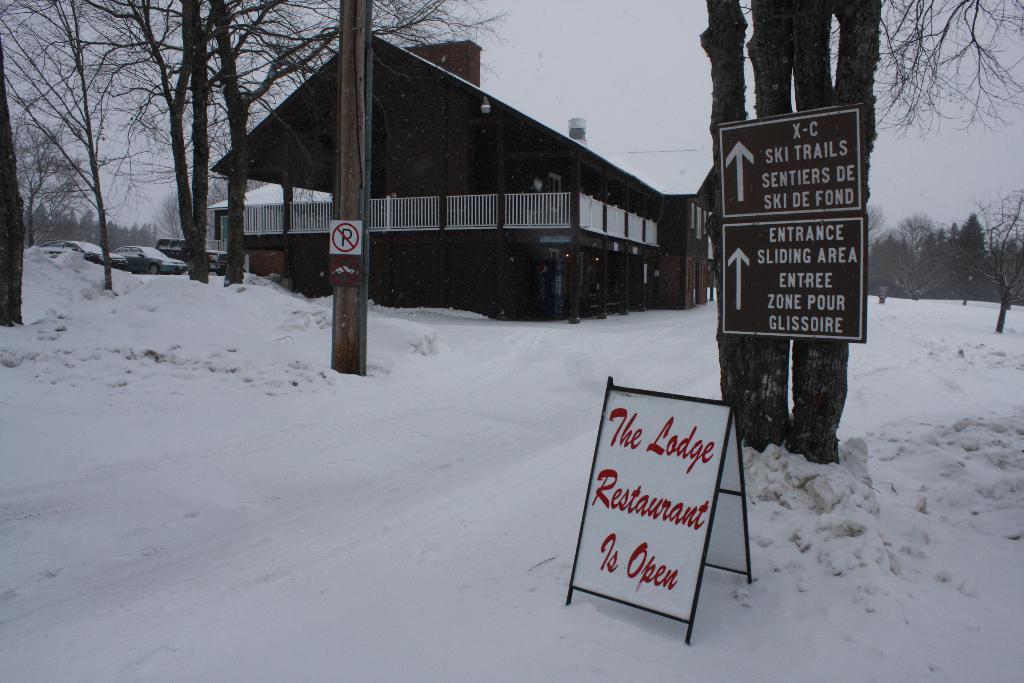Could you give a brief overview of what you see in this image? In this image I can see a board, sign boards, trees and a pole. There is a building at the back. There are cars on the left. There is snow. 